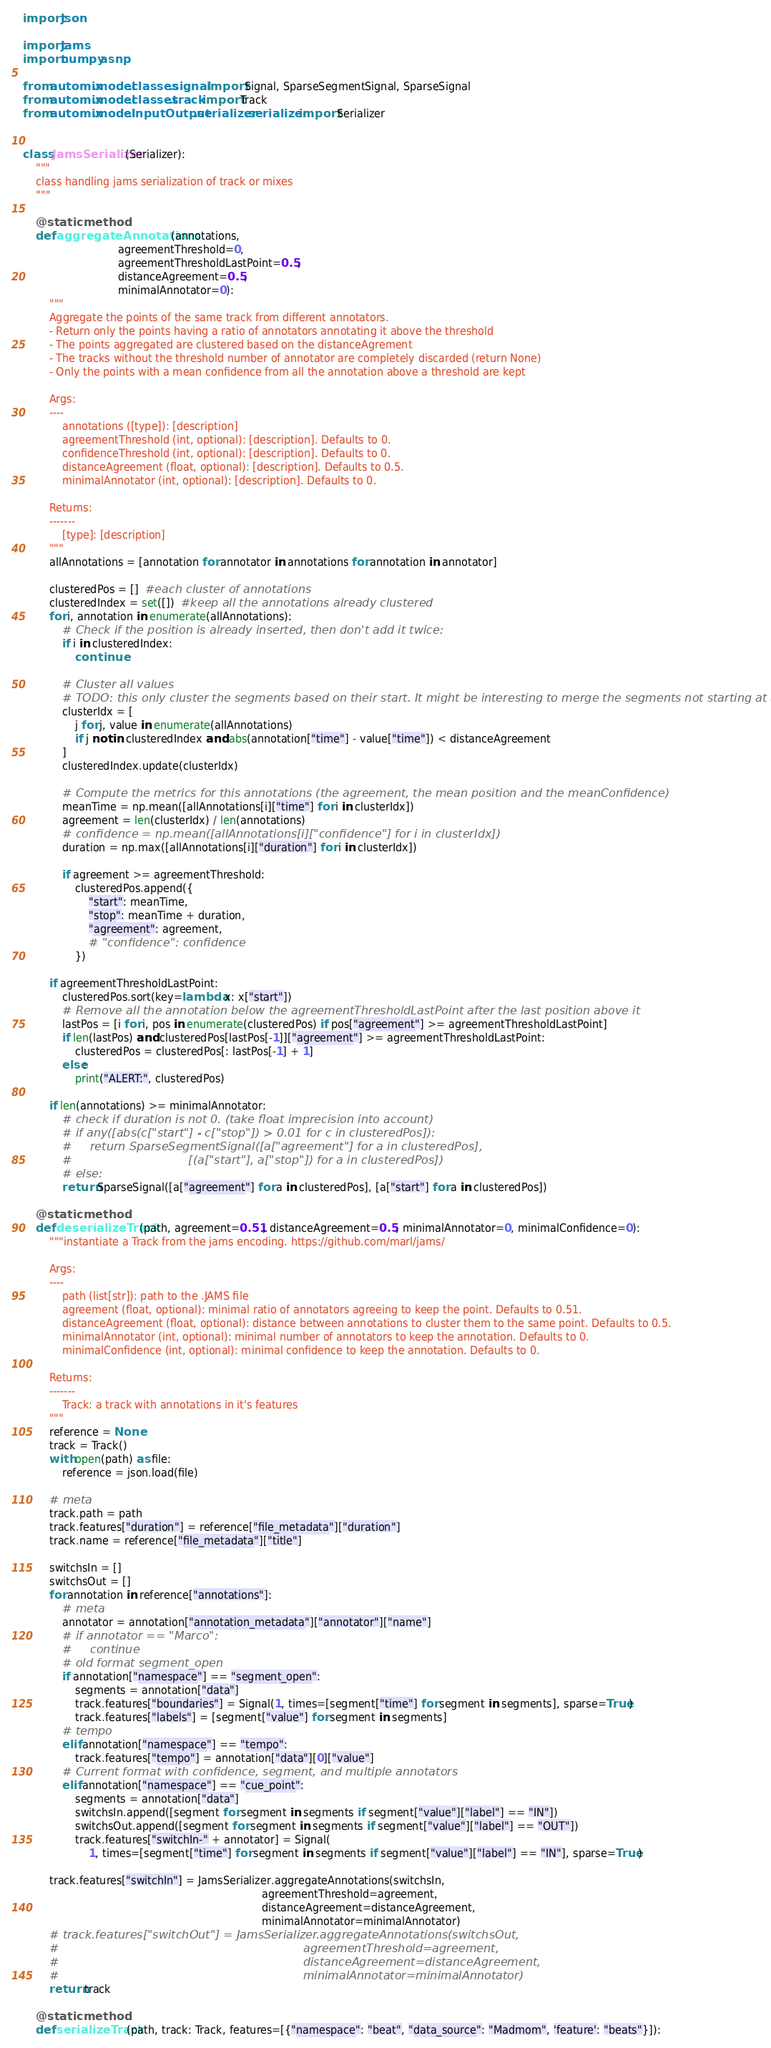Convert code to text. <code><loc_0><loc_0><loc_500><loc_500><_Python_>import json

import jams
import numpy as np

from automix.model.classes.signal import Signal, SparseSegmentSignal, SparseSignal
from automix.model.classes.track import Track
from automix.model.inputOutput.serializer.serializer import Serializer


class JamsSerializer(Serializer):
    """
    class handling jams serialization of track or mixes
    """

    @staticmethod
    def aggregateAnnotations(annotations,
                             agreementThreshold=0,
                             agreementThresholdLastPoint=0.5,
                             distanceAgreement=0.5,
                             minimalAnnotator=0):
        """        
        Aggregate the points of the same track from different annotators.
        - Return only the points having a ratio of annotators annotating it above the threshold 
        - The points aggregated are clustered based on the distanceAgrement
        - The tracks without the threshold number of annotator are completely discarded (return None)
        - Only the points with a mean confidence from all the annotation above a threshold are kept
        
        Args:
        ----
            annotations ([type]): [description]
            agreementThreshold (int, optional): [description]. Defaults to 0.
            confidenceThreshold (int, optional): [description]. Defaults to 0.
            distanceAgreement (float, optional): [description]. Defaults to 0.5.
            minimalAnnotator (int, optional): [description]. Defaults to 0.
        
        Returns:
        -------
            [type]: [description]
        """
        allAnnotations = [annotation for annotator in annotations for annotation in annotator]

        clusteredPos = []  #each cluster of annotations
        clusteredIndex = set([])  #keep all the annotations already clustered
        for i, annotation in enumerate(allAnnotations):
            # Check if the position is already inserted, then don't add it twice:
            if i in clusteredIndex:
                continue

            # Cluster all values
            # TODO: this only cluster the segments based on their start. It might be interesting to merge the segments not starting at all locations
            clusterIdx = [
                j for j, value in enumerate(allAnnotations)
                if j not in clusteredIndex and abs(annotation["time"] - value["time"]) < distanceAgreement
            ]
            clusteredIndex.update(clusterIdx)

            # Compute the metrics for this annotations (the agreement, the mean position and the meanConfidence)
            meanTime = np.mean([allAnnotations[i]["time"] for i in clusterIdx])
            agreement = len(clusterIdx) / len(annotations)
            # confidence = np.mean([allAnnotations[i]["confidence"] for i in clusterIdx])
            duration = np.max([allAnnotations[i]["duration"] for i in clusterIdx])

            if agreement >= agreementThreshold:
                clusteredPos.append({
                    "start": meanTime,
                    "stop": meanTime + duration,
                    "agreement": agreement,
                    # "confidence": confidence
                })

        if agreementThresholdLastPoint:
            clusteredPos.sort(key=lambda x: x["start"])
            # Remove all the annotation below the agreementThresholdLastPoint after the last position above it
            lastPos = [i for i, pos in enumerate(clusteredPos) if pos["agreement"] >= agreementThresholdLastPoint]
            if len(lastPos) and clusteredPos[lastPos[-1]]["agreement"] >= agreementThresholdLastPoint:
                clusteredPos = clusteredPos[: lastPos[-1] + 1]
            else:
                print("ALERT:", clusteredPos)

        if len(annotations) >= minimalAnnotator:
            # check if duration is not 0. (take float imprecision into account)
            # if any([abs(c["start"] - c["stop"]) > 0.01 for c in clusteredPos]):
            #     return SparseSegmentSignal([a["agreement"] for a in clusteredPos],
            #                                [(a["start"], a["stop"]) for a in clusteredPos])
            # else:
            return SparseSignal([a["agreement"] for a in clusteredPos], [a["start"] for a in clusteredPos])

    @staticmethod
    def deserializeTrack(path, agreement=0.51, distanceAgreement=0.5, minimalAnnotator=0, minimalConfidence=0):
        """instantiate a Track from the jams encoding. https://github.com/marl/jams/
        
        Args:
        ----
            path (list[str]): path to the .JAMS file
            agreement (float, optional): minimal ratio of annotators agreeing to keep the point. Defaults to 0.51.
            distanceAgreement (float, optional): distance between annotations to cluster them to the same point. Defaults to 0.5.
            minimalAnnotator (int, optional): minimal number of annotators to keep the annotation. Defaults to 0.
            minimalConfidence (int, optional): minimal confidence to keep the annotation. Defaults to 0.
        
        Returns:
        -------
            Track: a track with annotations in it's features
        """
        reference = None
        track = Track()
        with open(path) as file:
            reference = json.load(file)

        # meta
        track.path = path
        track.features["duration"] = reference["file_metadata"]["duration"]
        track.name = reference["file_metadata"]["title"]

        switchsIn = []
        switchsOut = []
        for annotation in reference["annotations"]:
            # meta
            annotator = annotation["annotation_metadata"]["annotator"]["name"]
            # if annotator == "Marco":
            #     continue
            # old format segment_open
            if annotation["namespace"] == "segment_open":
                segments = annotation["data"]
                track.features["boundaries"] = Signal(1, times=[segment["time"] for segment in segments], sparse=True)
                track.features["labels"] = [segment["value"] for segment in segments]
            # tempo
            elif annotation["namespace"] == "tempo":
                track.features["tempo"] = annotation["data"][0]["value"]
            # Current format with confidence, segment, and multiple annotators
            elif annotation["namespace"] == "cue_point":
                segments = annotation["data"]
                switchsIn.append([segment for segment in segments if segment["value"]["label"] == "IN"])
                switchsOut.append([segment for segment in segments if segment["value"]["label"] == "OUT"])
                track.features["switchIn-" + annotator] = Signal(
                    1, times=[segment["time"] for segment in segments if segment["value"]["label"] == "IN"], sparse=True)

        track.features["switchIn"] = JamsSerializer.aggregateAnnotations(switchsIn,
                                                                         agreementThreshold=agreement,
                                                                         distanceAgreement=distanceAgreement,
                                                                         minimalAnnotator=minimalAnnotator)
        # track.features["switchOut"] = JamsSerializer.aggregateAnnotations(switchsOut,
        #                                                                   agreementThreshold=agreement,
        #                                                                   distanceAgreement=distanceAgreement,
        #                                                                   minimalAnnotator=minimalAnnotator)
        return track

    @staticmethod
    def serializeTrack(path, track: Track, features=[{"namespace": "beat", "data_source": "Madmom", 'feature': "beats"}]):</code> 